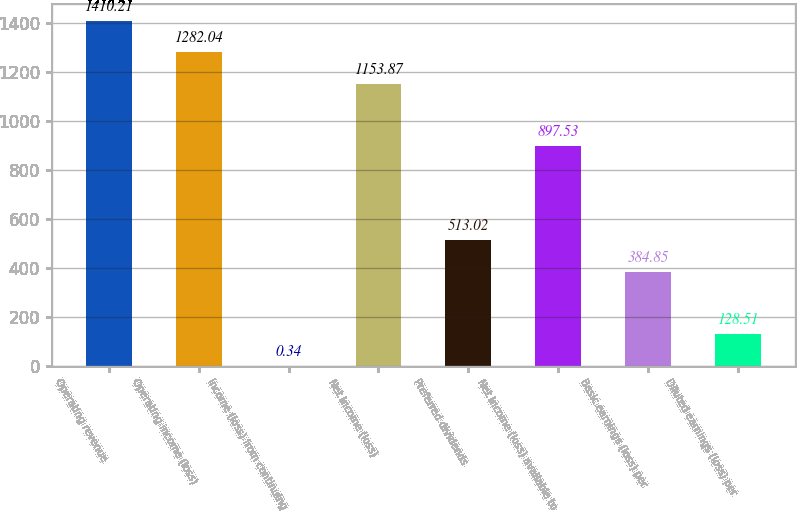<chart> <loc_0><loc_0><loc_500><loc_500><bar_chart><fcel>Operating revenue<fcel>Operating income (loss)<fcel>Income (loss) from continuing<fcel>Net income (loss)<fcel>Preferred dividends<fcel>Net income (loss) available to<fcel>Basic earnings (loss) per<fcel>Diluted earnings (loss) per<nl><fcel>1410.21<fcel>1282.04<fcel>0.34<fcel>1153.87<fcel>513.02<fcel>897.53<fcel>384.85<fcel>128.51<nl></chart> 